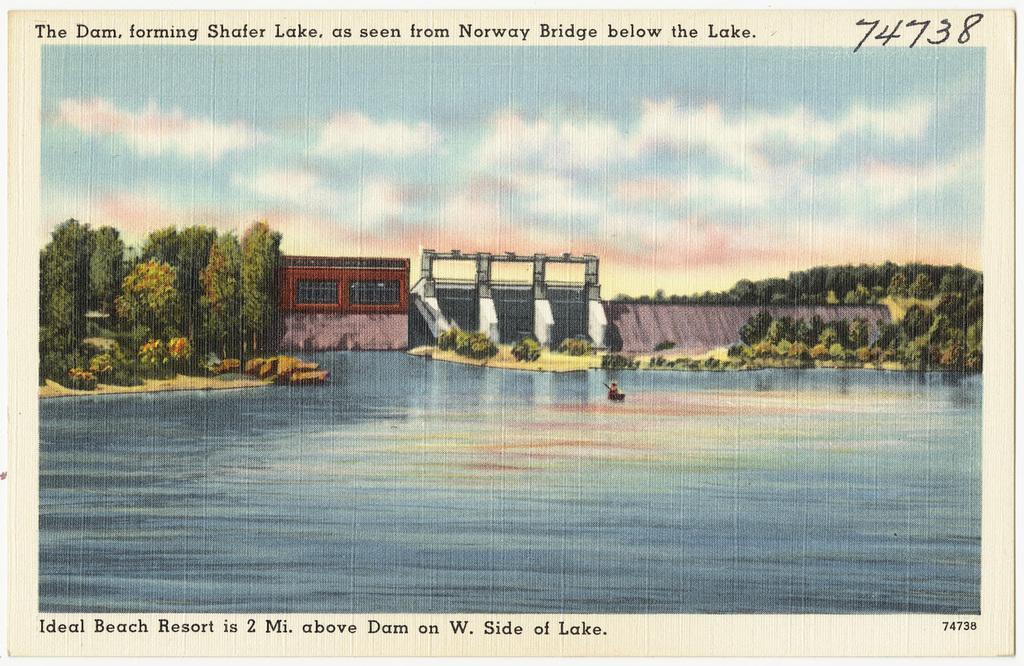What type of image is this? The image appears to be an edited photo. What can be seen in the image besides the edited photo? There is text, water, a boat, trees, grass, stones, a fence, a wall, the sky, and a house visible in the image. Where is the pocket located in the image? There is no pocket present in the image. What type of boundary can be seen in the image? There is no specific boundary mentioned in the provided facts, but there is a fence and a wall visible in the image. How many hydrants are visible in the image? There is no hydrant present in the image. 